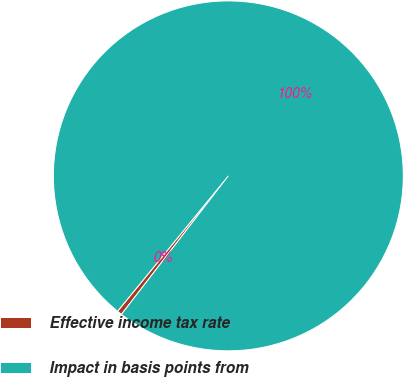Convert chart to OTSL. <chart><loc_0><loc_0><loc_500><loc_500><pie_chart><fcel>Effective income tax rate<fcel>Impact in basis points from<nl><fcel>0.45%<fcel>99.55%<nl></chart> 